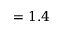<formula> <loc_0><loc_0><loc_500><loc_500>= 1 . 4</formula> 